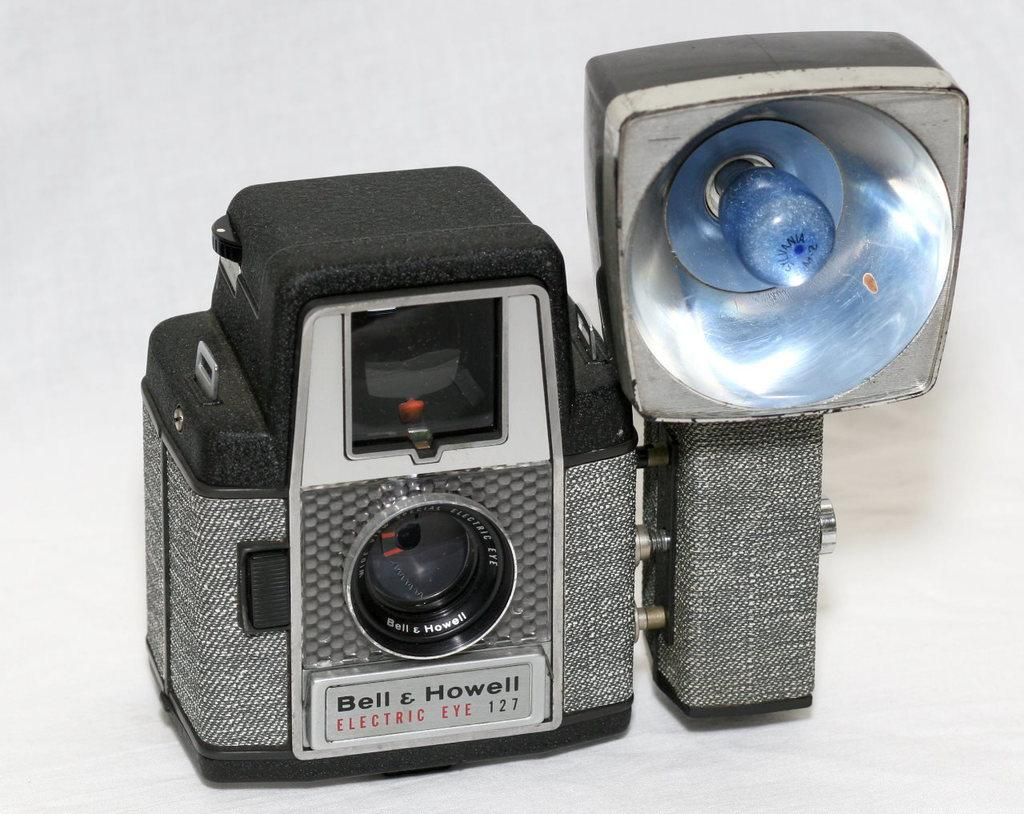Provide a one-sentence caption for the provided image. A Bell & Howell camera with flash mount. 